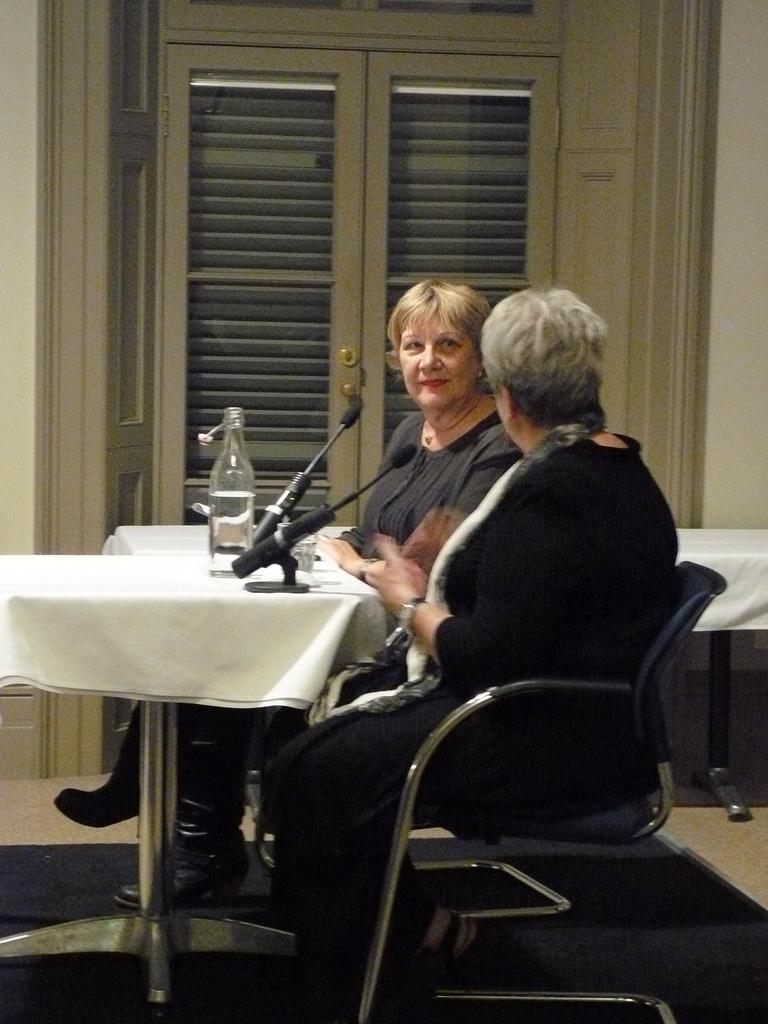How many people are sitting on the chair in the image? There are two persons sitting on a chair in the image. What object is present that is typically used for amplifying sound? There is a microphone in the image. What can be seen on the table in the image? There is a bottle on a table in the image. What architectural feature is visible in the background of the image? There is a door visible in the background of the image. What type of chess pieces can be seen on the table in the image? There are no chess pieces present in the image; it features a bottle on a table. How many dogs are visible in the image? There are no dogs present in the image. 